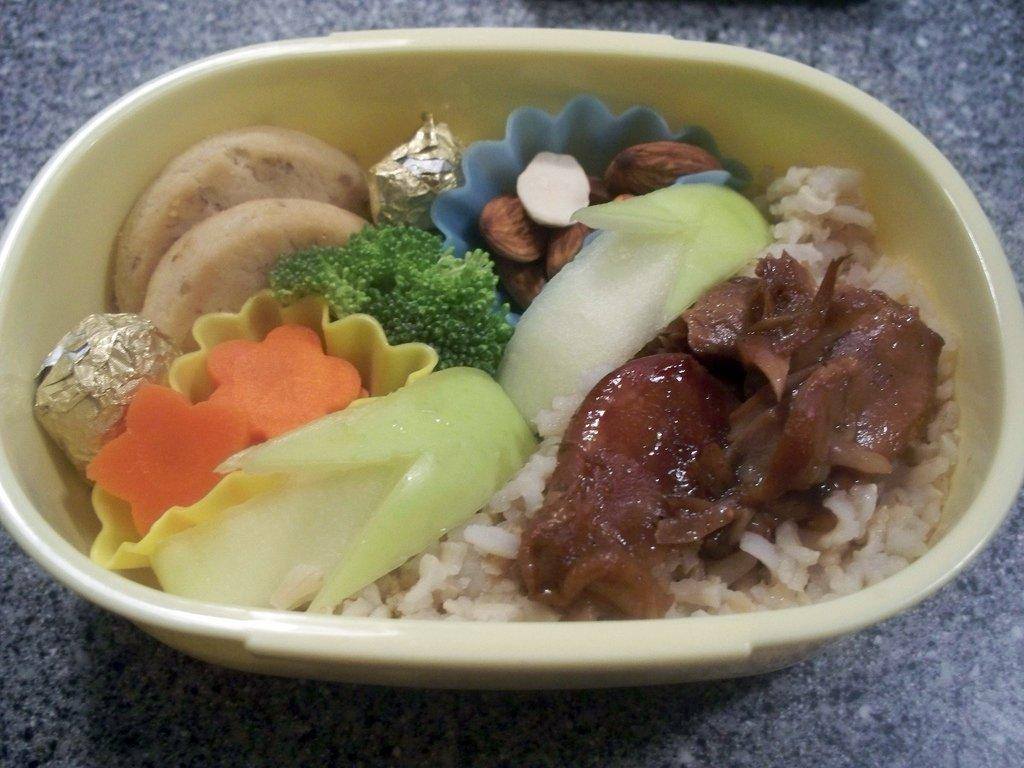What is in the bowl that is visible in the image? There are food items in a bowl. Where is the bowl located in the image? The bowl is placed on the floor. What type of sleet can be seen falling in the image? There is no sleet present in the image. What type of pickle is visible in the image? There is no pickle present in the image. 